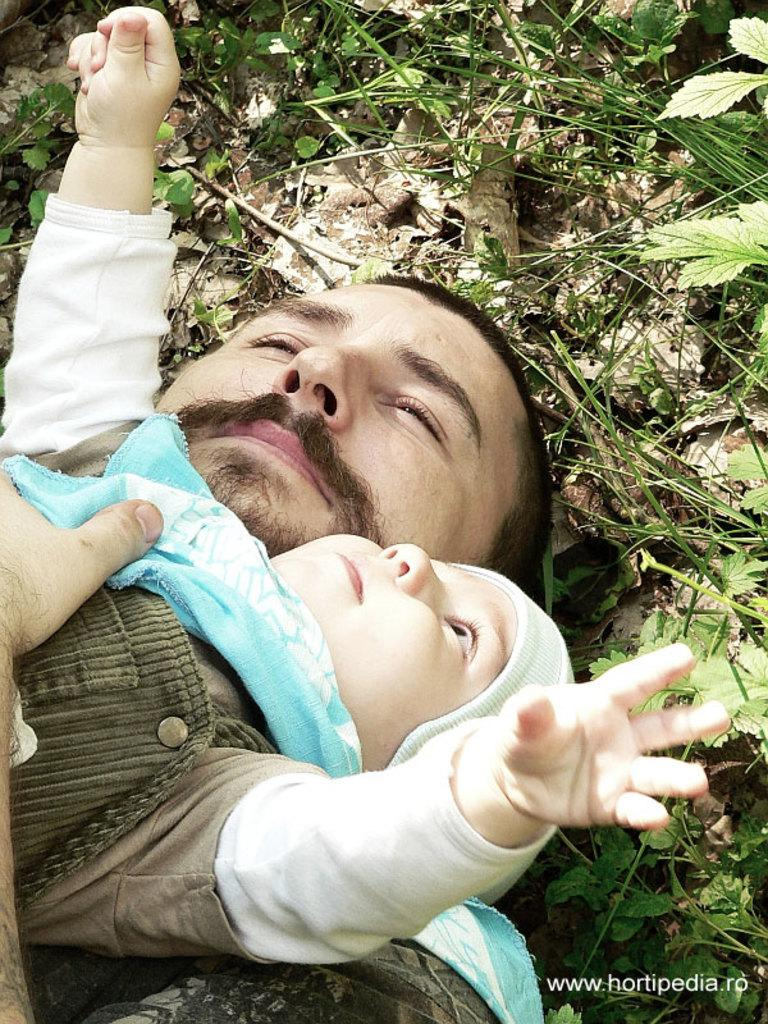What is the main subject of the image? There is a baby in the image. What is the baby wearing? The baby is wearing a cap. How is the baby positioned in the image? The baby is lying on a man. What can be seen in the background of the image? There are plants and some text visible in the background. What type of tools does the carpenter have in the image? There is no carpenter present in the image, so no tools can be observed. What color is the coat that the baby is wearing in the image? The baby is not wearing a coat in the image; they are wearing a cap. 